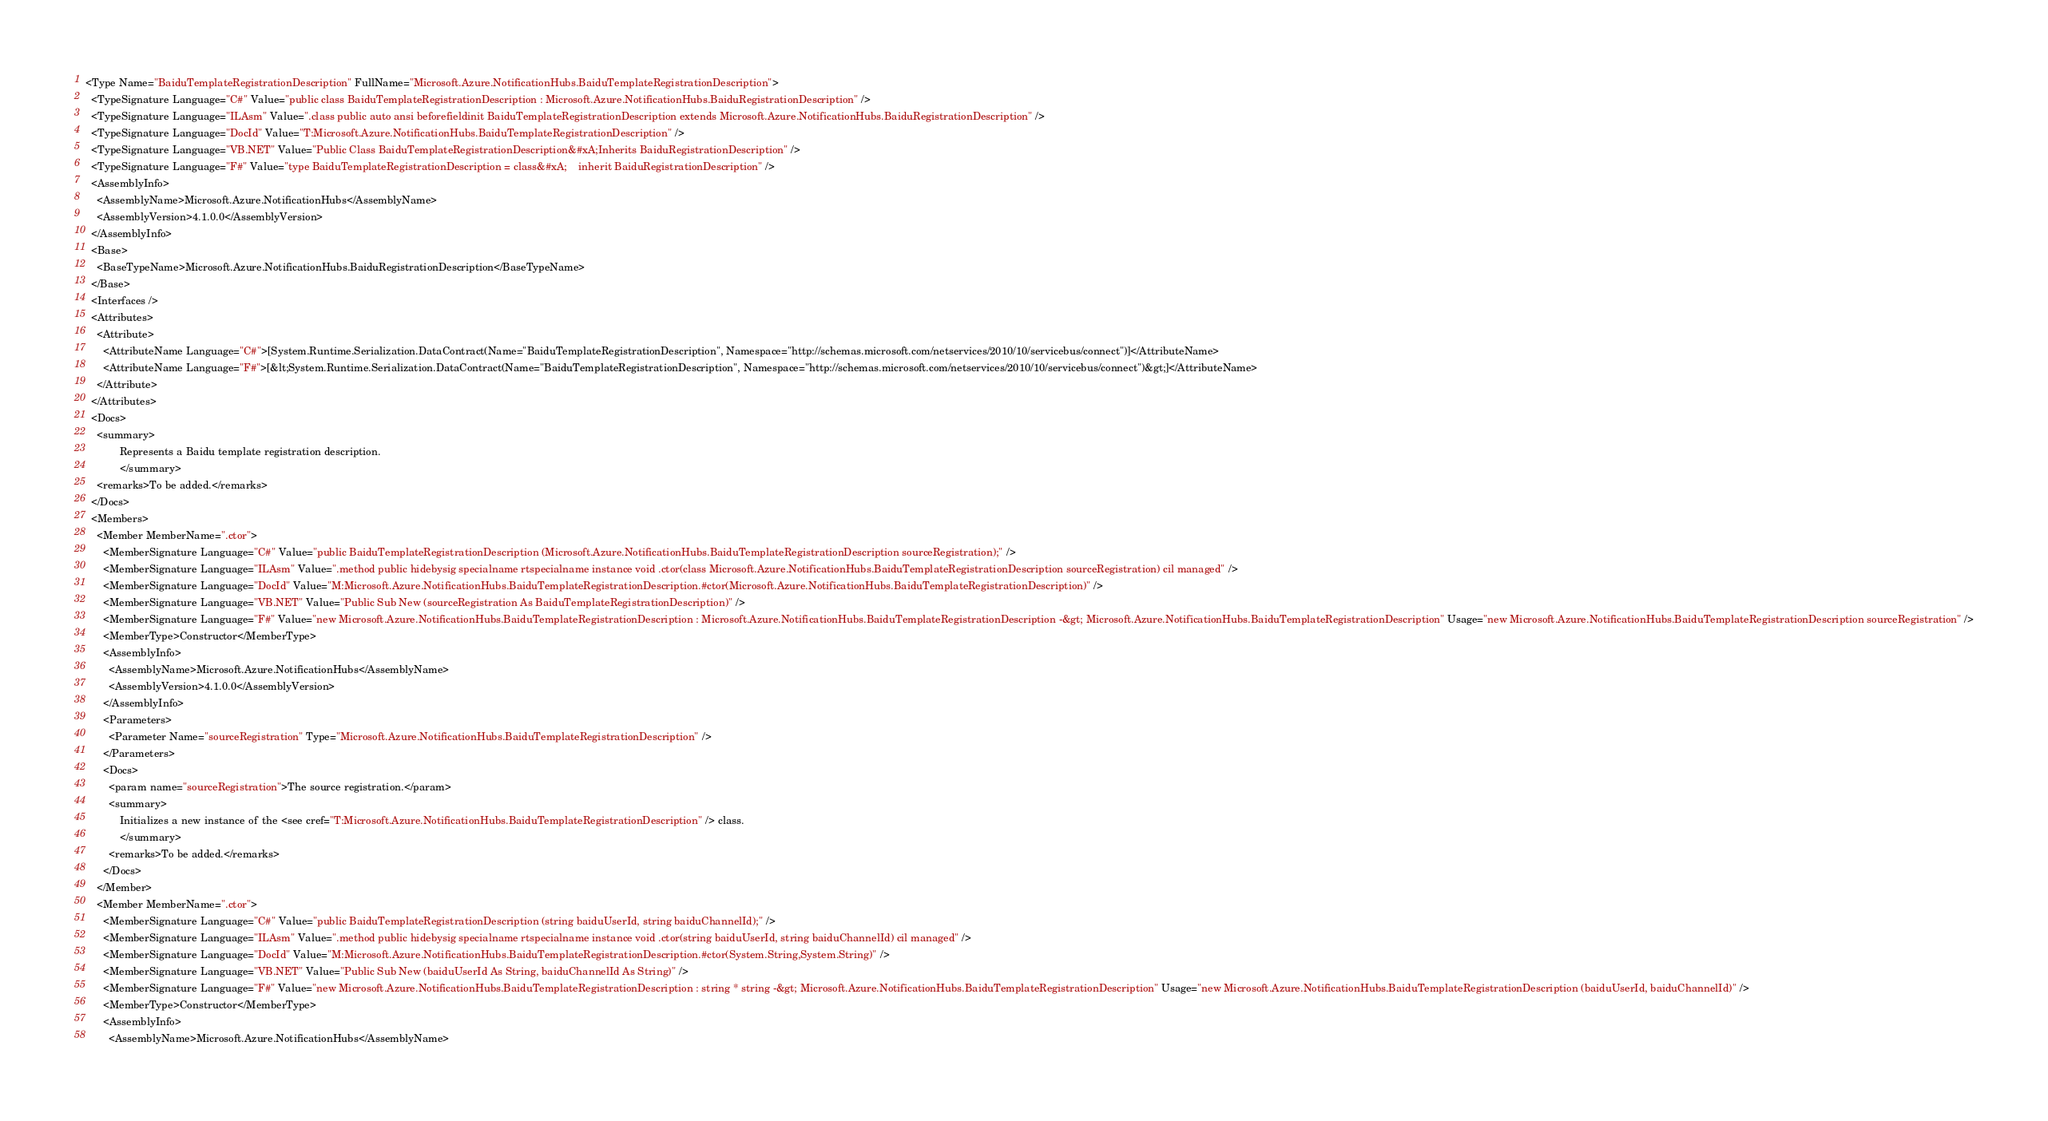<code> <loc_0><loc_0><loc_500><loc_500><_XML_><Type Name="BaiduTemplateRegistrationDescription" FullName="Microsoft.Azure.NotificationHubs.BaiduTemplateRegistrationDescription">
  <TypeSignature Language="C#" Value="public class BaiduTemplateRegistrationDescription : Microsoft.Azure.NotificationHubs.BaiduRegistrationDescription" />
  <TypeSignature Language="ILAsm" Value=".class public auto ansi beforefieldinit BaiduTemplateRegistrationDescription extends Microsoft.Azure.NotificationHubs.BaiduRegistrationDescription" />
  <TypeSignature Language="DocId" Value="T:Microsoft.Azure.NotificationHubs.BaiduTemplateRegistrationDescription" />
  <TypeSignature Language="VB.NET" Value="Public Class BaiduTemplateRegistrationDescription&#xA;Inherits BaiduRegistrationDescription" />
  <TypeSignature Language="F#" Value="type BaiduTemplateRegistrationDescription = class&#xA;    inherit BaiduRegistrationDescription" />
  <AssemblyInfo>
    <AssemblyName>Microsoft.Azure.NotificationHubs</AssemblyName>
    <AssemblyVersion>4.1.0.0</AssemblyVersion>
  </AssemblyInfo>
  <Base>
    <BaseTypeName>Microsoft.Azure.NotificationHubs.BaiduRegistrationDescription</BaseTypeName>
  </Base>
  <Interfaces />
  <Attributes>
    <Attribute>
      <AttributeName Language="C#">[System.Runtime.Serialization.DataContract(Name="BaiduTemplateRegistrationDescription", Namespace="http://schemas.microsoft.com/netservices/2010/10/servicebus/connect")]</AttributeName>
      <AttributeName Language="F#">[&lt;System.Runtime.Serialization.DataContract(Name="BaiduTemplateRegistrationDescription", Namespace="http://schemas.microsoft.com/netservices/2010/10/servicebus/connect")&gt;]</AttributeName>
    </Attribute>
  </Attributes>
  <Docs>
    <summary>
            Represents a Baidu template registration description.
            </summary>
    <remarks>To be added.</remarks>
  </Docs>
  <Members>
    <Member MemberName=".ctor">
      <MemberSignature Language="C#" Value="public BaiduTemplateRegistrationDescription (Microsoft.Azure.NotificationHubs.BaiduTemplateRegistrationDescription sourceRegistration);" />
      <MemberSignature Language="ILAsm" Value=".method public hidebysig specialname rtspecialname instance void .ctor(class Microsoft.Azure.NotificationHubs.BaiduTemplateRegistrationDescription sourceRegistration) cil managed" />
      <MemberSignature Language="DocId" Value="M:Microsoft.Azure.NotificationHubs.BaiduTemplateRegistrationDescription.#ctor(Microsoft.Azure.NotificationHubs.BaiduTemplateRegistrationDescription)" />
      <MemberSignature Language="VB.NET" Value="Public Sub New (sourceRegistration As BaiduTemplateRegistrationDescription)" />
      <MemberSignature Language="F#" Value="new Microsoft.Azure.NotificationHubs.BaiduTemplateRegistrationDescription : Microsoft.Azure.NotificationHubs.BaiduTemplateRegistrationDescription -&gt; Microsoft.Azure.NotificationHubs.BaiduTemplateRegistrationDescription" Usage="new Microsoft.Azure.NotificationHubs.BaiduTemplateRegistrationDescription sourceRegistration" />
      <MemberType>Constructor</MemberType>
      <AssemblyInfo>
        <AssemblyName>Microsoft.Azure.NotificationHubs</AssemblyName>
        <AssemblyVersion>4.1.0.0</AssemblyVersion>
      </AssemblyInfo>
      <Parameters>
        <Parameter Name="sourceRegistration" Type="Microsoft.Azure.NotificationHubs.BaiduTemplateRegistrationDescription" />
      </Parameters>
      <Docs>
        <param name="sourceRegistration">The source registration.</param>
        <summary>
            Initializes a new instance of the <see cref="T:Microsoft.Azure.NotificationHubs.BaiduTemplateRegistrationDescription" /> class.
            </summary>
        <remarks>To be added.</remarks>
      </Docs>
    </Member>
    <Member MemberName=".ctor">
      <MemberSignature Language="C#" Value="public BaiduTemplateRegistrationDescription (string baiduUserId, string baiduChannelId);" />
      <MemberSignature Language="ILAsm" Value=".method public hidebysig specialname rtspecialname instance void .ctor(string baiduUserId, string baiduChannelId) cil managed" />
      <MemberSignature Language="DocId" Value="M:Microsoft.Azure.NotificationHubs.BaiduTemplateRegistrationDescription.#ctor(System.String,System.String)" />
      <MemberSignature Language="VB.NET" Value="Public Sub New (baiduUserId As String, baiduChannelId As String)" />
      <MemberSignature Language="F#" Value="new Microsoft.Azure.NotificationHubs.BaiduTemplateRegistrationDescription : string * string -&gt; Microsoft.Azure.NotificationHubs.BaiduTemplateRegistrationDescription" Usage="new Microsoft.Azure.NotificationHubs.BaiduTemplateRegistrationDescription (baiduUserId, baiduChannelId)" />
      <MemberType>Constructor</MemberType>
      <AssemblyInfo>
        <AssemblyName>Microsoft.Azure.NotificationHubs</AssemblyName></code> 